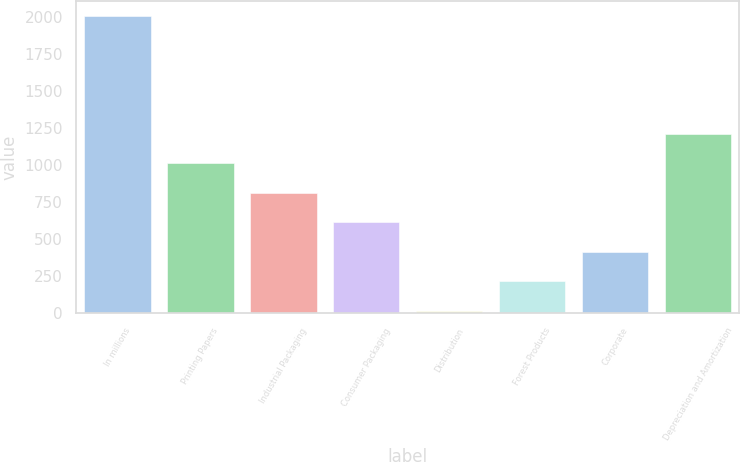Convert chart to OTSL. <chart><loc_0><loc_0><loc_500><loc_500><bar_chart><fcel>In millions<fcel>Printing Papers<fcel>Industrial Packaging<fcel>Consumer Packaging<fcel>Distribution<fcel>Forest Products<fcel>Corporate<fcel>Depreciation and Amortization<nl><fcel>2006<fcel>1012<fcel>813.2<fcel>614.4<fcel>18<fcel>216.8<fcel>415.6<fcel>1210.8<nl></chart> 